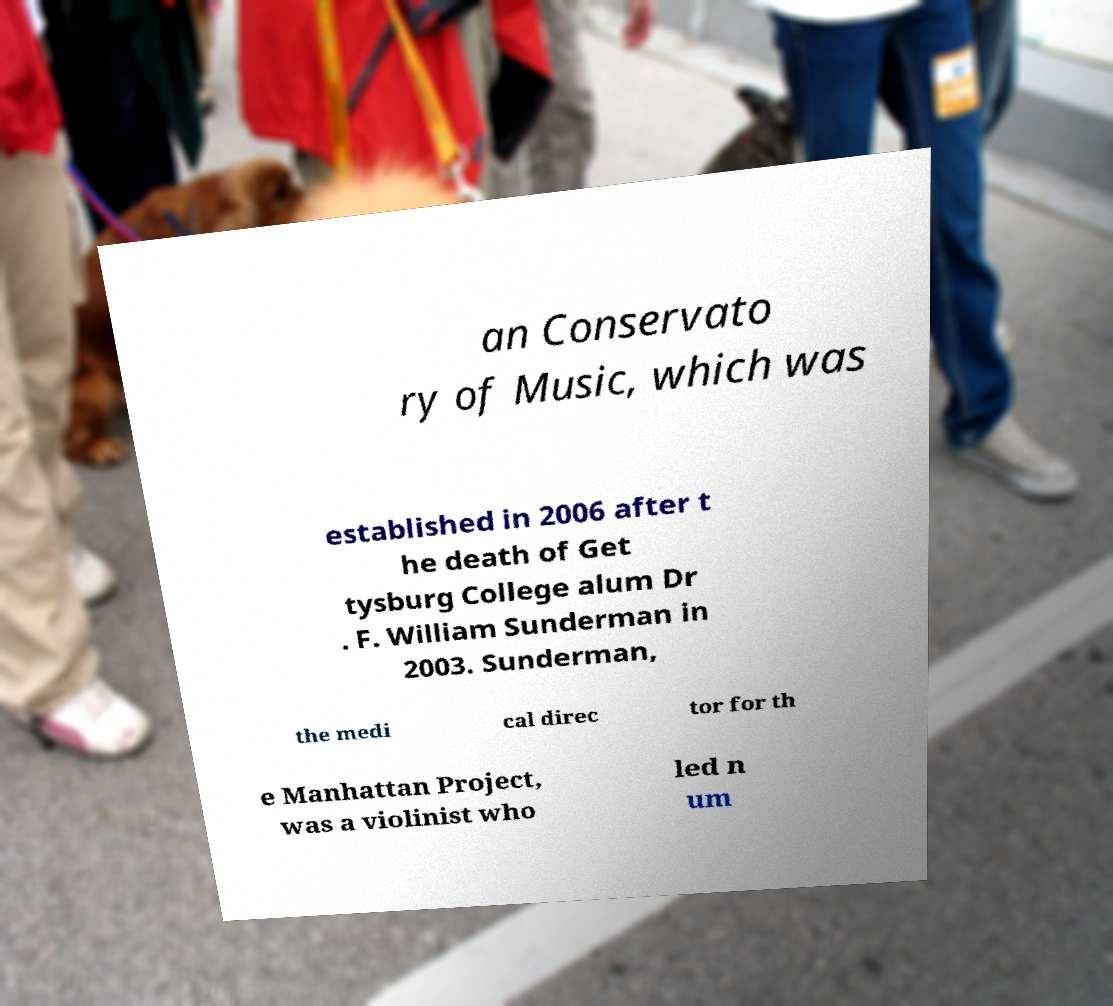For documentation purposes, I need the text within this image transcribed. Could you provide that? an Conservato ry of Music, which was established in 2006 after t he death of Get tysburg College alum Dr . F. William Sunderman in 2003. Sunderman, the medi cal direc tor for th e Manhattan Project, was a violinist who led n um 